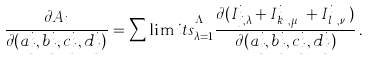<formula> <loc_0><loc_0><loc_500><loc_500>\frac { \partial A _ { i } } { \partial ( a _ { j } ^ { i } , b _ { j } ^ { i } , c _ { j } ^ { i } , d _ { j } ^ { i } ) } = \sum \lim i t s _ { \lambda = 1 } ^ { \Lambda _ { j } ^ { i } } \frac { \partial ( I _ { j , \lambda } ^ { i } + I _ { k _ { \lambda } , \mu _ { \lambda } } ^ { i } + I _ { l _ { \lambda } , \nu _ { \lambda } } ^ { i } ) } { \partial ( a _ { j } ^ { i } , b _ { j } ^ { i } , c _ { j } ^ { i } , d _ { j } ^ { i } ) } \, .</formula> 